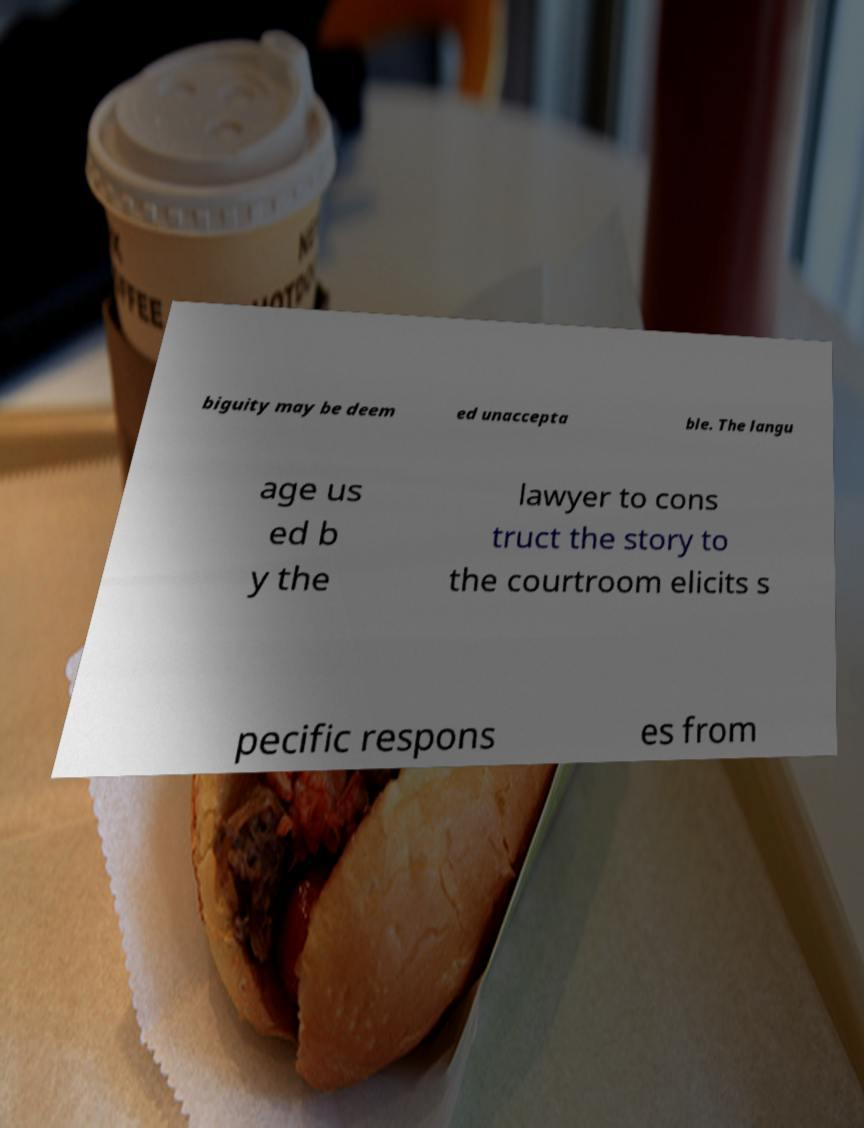For documentation purposes, I need the text within this image transcribed. Could you provide that? biguity may be deem ed unaccepta ble. The langu age us ed b y the lawyer to cons truct the story to the courtroom elicits s pecific respons es from 